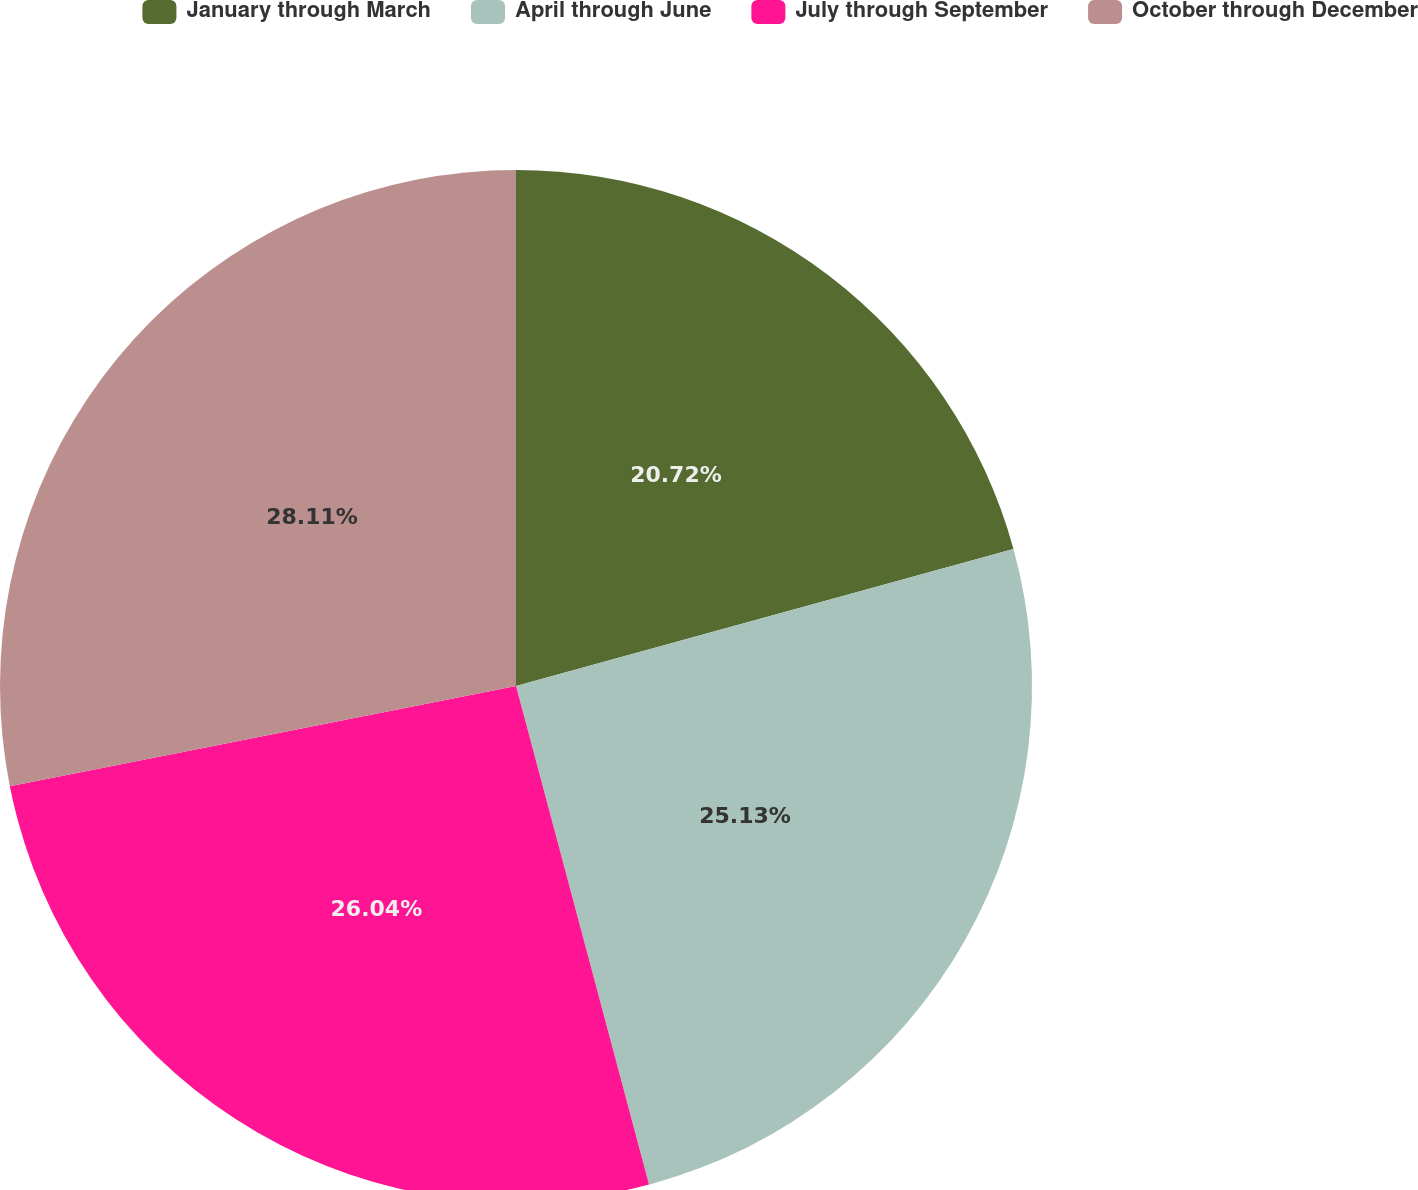Convert chart to OTSL. <chart><loc_0><loc_0><loc_500><loc_500><pie_chart><fcel>January through March<fcel>April through June<fcel>July through September<fcel>October through December<nl><fcel>20.72%<fcel>25.13%<fcel>26.04%<fcel>28.11%<nl></chart> 